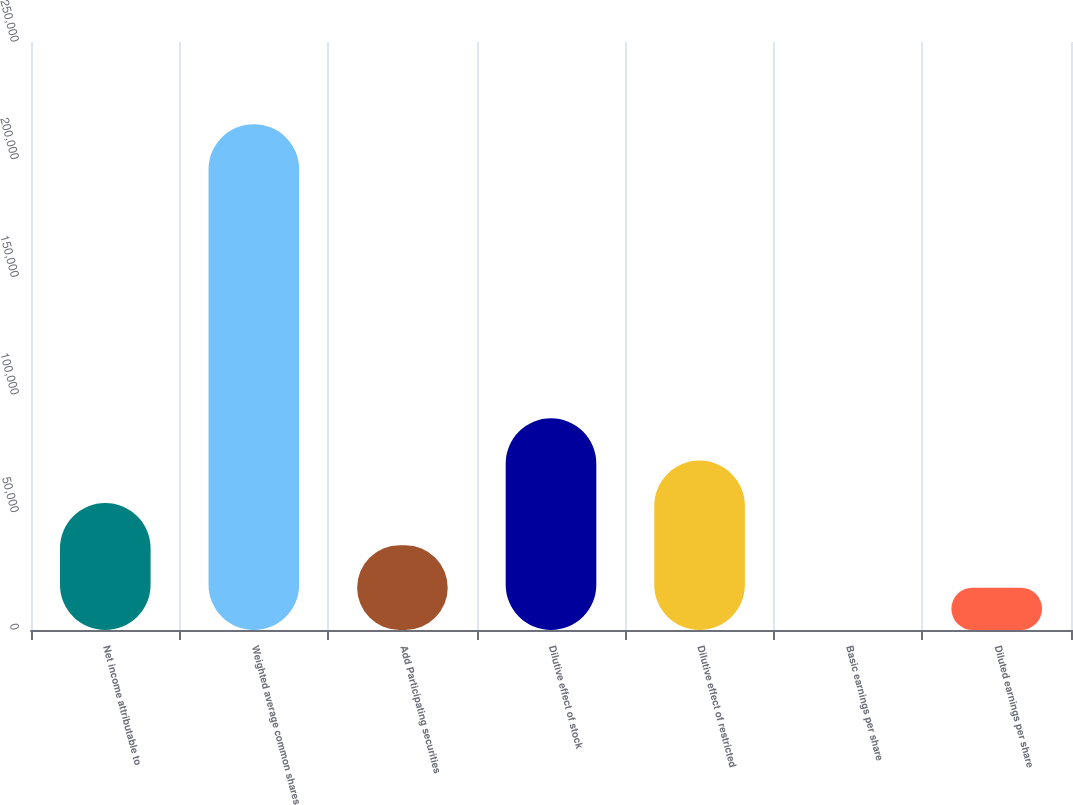Convert chart. <chart><loc_0><loc_0><loc_500><loc_500><bar_chart><fcel>Net income attributable to<fcel>Weighted average common shares<fcel>Add Participating securities<fcel>Dilutive effect of stock<fcel>Dilutive effect of restricted<fcel>Basic earnings per share<fcel>Diluted earnings per share<nl><fcel>54012.4<fcel>215076<fcel>36008.8<fcel>90019.7<fcel>72016.1<fcel>1.45<fcel>18005.1<nl></chart> 